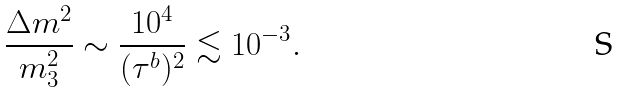<formula> <loc_0><loc_0><loc_500><loc_500>\frac { \Delta m ^ { 2 } } { m _ { 3 } ^ { 2 } } \sim \frac { 1 0 ^ { 4 } } { ( \tau ^ { b } ) ^ { 2 } } \lesssim 1 0 ^ { - 3 } .</formula> 